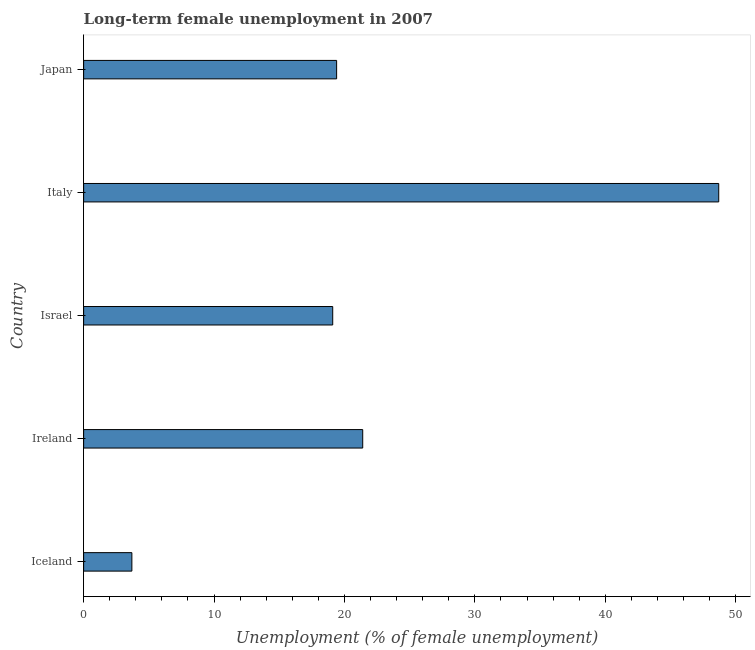Does the graph contain grids?
Keep it short and to the point. No. What is the title of the graph?
Offer a terse response. Long-term female unemployment in 2007. What is the label or title of the X-axis?
Your response must be concise. Unemployment (% of female unemployment). What is the label or title of the Y-axis?
Your response must be concise. Country. What is the long-term female unemployment in Japan?
Your answer should be very brief. 19.4. Across all countries, what is the maximum long-term female unemployment?
Make the answer very short. 48.7. Across all countries, what is the minimum long-term female unemployment?
Provide a succinct answer. 3.7. In which country was the long-term female unemployment minimum?
Your answer should be very brief. Iceland. What is the sum of the long-term female unemployment?
Provide a short and direct response. 112.3. What is the difference between the long-term female unemployment in Italy and Japan?
Give a very brief answer. 29.3. What is the average long-term female unemployment per country?
Your answer should be very brief. 22.46. What is the median long-term female unemployment?
Provide a short and direct response. 19.4. In how many countries, is the long-term female unemployment greater than 12 %?
Give a very brief answer. 4. What is the ratio of the long-term female unemployment in Ireland to that in Japan?
Provide a succinct answer. 1.1. Is the long-term female unemployment in Iceland less than that in Ireland?
Ensure brevity in your answer.  Yes. Is the difference between the long-term female unemployment in Iceland and Italy greater than the difference between any two countries?
Your answer should be compact. Yes. What is the difference between the highest and the second highest long-term female unemployment?
Your answer should be very brief. 27.3. Is the sum of the long-term female unemployment in Israel and Italy greater than the maximum long-term female unemployment across all countries?
Give a very brief answer. Yes. What is the difference between the highest and the lowest long-term female unemployment?
Give a very brief answer. 45. What is the difference between two consecutive major ticks on the X-axis?
Provide a short and direct response. 10. Are the values on the major ticks of X-axis written in scientific E-notation?
Keep it short and to the point. No. What is the Unemployment (% of female unemployment) in Iceland?
Give a very brief answer. 3.7. What is the Unemployment (% of female unemployment) of Ireland?
Provide a short and direct response. 21.4. What is the Unemployment (% of female unemployment) of Israel?
Provide a succinct answer. 19.1. What is the Unemployment (% of female unemployment) in Italy?
Provide a short and direct response. 48.7. What is the Unemployment (% of female unemployment) of Japan?
Keep it short and to the point. 19.4. What is the difference between the Unemployment (% of female unemployment) in Iceland and Ireland?
Give a very brief answer. -17.7. What is the difference between the Unemployment (% of female unemployment) in Iceland and Israel?
Provide a succinct answer. -15.4. What is the difference between the Unemployment (% of female unemployment) in Iceland and Italy?
Your response must be concise. -45. What is the difference between the Unemployment (% of female unemployment) in Iceland and Japan?
Your answer should be compact. -15.7. What is the difference between the Unemployment (% of female unemployment) in Ireland and Italy?
Give a very brief answer. -27.3. What is the difference between the Unemployment (% of female unemployment) in Ireland and Japan?
Provide a succinct answer. 2. What is the difference between the Unemployment (% of female unemployment) in Israel and Italy?
Make the answer very short. -29.6. What is the difference between the Unemployment (% of female unemployment) in Italy and Japan?
Your answer should be compact. 29.3. What is the ratio of the Unemployment (% of female unemployment) in Iceland to that in Ireland?
Offer a terse response. 0.17. What is the ratio of the Unemployment (% of female unemployment) in Iceland to that in Israel?
Provide a succinct answer. 0.19. What is the ratio of the Unemployment (% of female unemployment) in Iceland to that in Italy?
Your response must be concise. 0.08. What is the ratio of the Unemployment (% of female unemployment) in Iceland to that in Japan?
Provide a succinct answer. 0.19. What is the ratio of the Unemployment (% of female unemployment) in Ireland to that in Israel?
Ensure brevity in your answer.  1.12. What is the ratio of the Unemployment (% of female unemployment) in Ireland to that in Italy?
Your response must be concise. 0.44. What is the ratio of the Unemployment (% of female unemployment) in Ireland to that in Japan?
Provide a succinct answer. 1.1. What is the ratio of the Unemployment (% of female unemployment) in Israel to that in Italy?
Keep it short and to the point. 0.39. What is the ratio of the Unemployment (% of female unemployment) in Italy to that in Japan?
Ensure brevity in your answer.  2.51. 